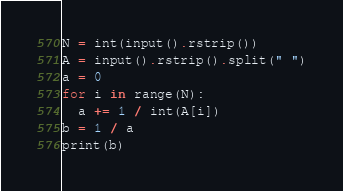<code> <loc_0><loc_0><loc_500><loc_500><_Python_>N = int(input().rstrip())
A = input().rstrip().split(" ")
a = 0
for i in range(N):
  a += 1 / int(A[i])
b = 1 / a
print(b)</code> 